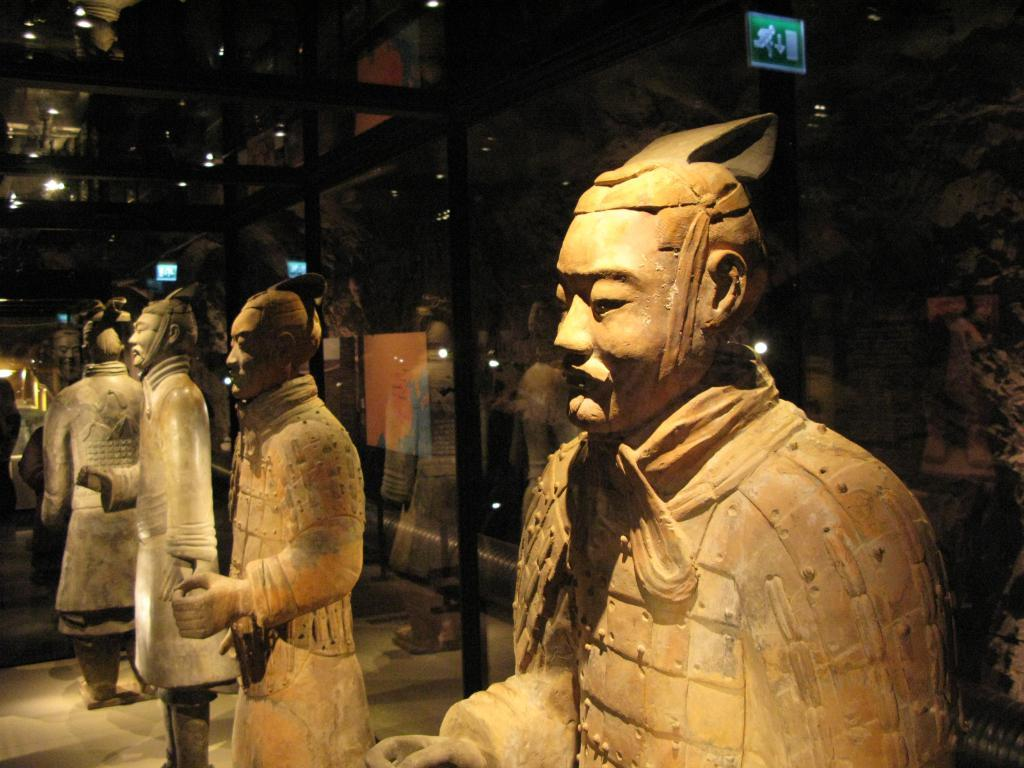What type of objects can be seen in the image? There are sculptures, glasses, and lights in the image. Where is the sign board located in the image? The sign board is in the top right corner of the image. Who is the creator of the quiet pleasure depicted in the image? There is no depiction of a quiet pleasure in the image, and therefore no creator can be identified. 